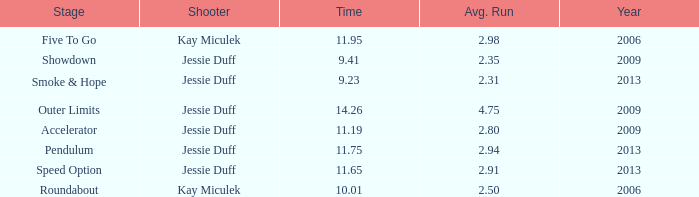What is the total years with average runs less than 4.75 and a time of 14.26? 0.0. 